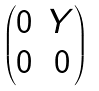<formula> <loc_0><loc_0><loc_500><loc_500>\begin{pmatrix} 0 & Y \\ 0 & 0 \\ \end{pmatrix}</formula> 